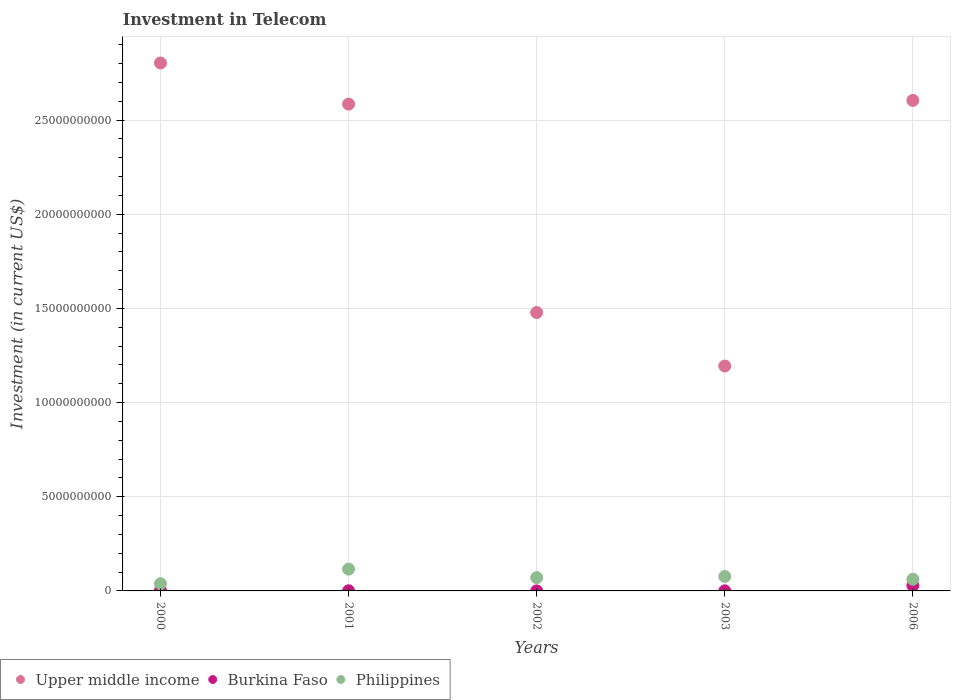How many different coloured dotlines are there?
Offer a very short reply. 3. What is the amount invested in telecom in Philippines in 2001?
Provide a short and direct response. 1.16e+09. Across all years, what is the maximum amount invested in telecom in Upper middle income?
Your response must be concise. 2.80e+1. Across all years, what is the minimum amount invested in telecom in Upper middle income?
Ensure brevity in your answer.  1.19e+1. In which year was the amount invested in telecom in Philippines minimum?
Offer a terse response. 2000. What is the total amount invested in telecom in Philippines in the graph?
Your response must be concise. 3.63e+09. What is the difference between the amount invested in telecom in Upper middle income in 2002 and that in 2003?
Ensure brevity in your answer.  2.84e+09. What is the difference between the amount invested in telecom in Philippines in 2003 and the amount invested in telecom in Burkina Faso in 2001?
Ensure brevity in your answer.  7.59e+08. What is the average amount invested in telecom in Upper middle income per year?
Ensure brevity in your answer.  2.13e+1. In the year 2003, what is the difference between the amount invested in telecom in Upper middle income and amount invested in telecom in Philippines?
Offer a very short reply. 1.12e+1. What is the ratio of the amount invested in telecom in Burkina Faso in 2000 to that in 2003?
Ensure brevity in your answer.  5.22. Is the amount invested in telecom in Philippines in 2000 less than that in 2003?
Provide a succinct answer. Yes. What is the difference between the highest and the second highest amount invested in telecom in Burkina Faso?
Ensure brevity in your answer.  2.63e+08. What is the difference between the highest and the lowest amount invested in telecom in Upper middle income?
Your response must be concise. 1.61e+1. Is the sum of the amount invested in telecom in Philippines in 2001 and 2003 greater than the maximum amount invested in telecom in Burkina Faso across all years?
Provide a succinct answer. Yes. Is it the case that in every year, the sum of the amount invested in telecom in Upper middle income and amount invested in telecom in Burkina Faso  is greater than the amount invested in telecom in Philippines?
Your answer should be compact. Yes. Does the amount invested in telecom in Upper middle income monotonically increase over the years?
Keep it short and to the point. No. Is the amount invested in telecom in Burkina Faso strictly less than the amount invested in telecom in Philippines over the years?
Offer a very short reply. Yes. How many dotlines are there?
Your response must be concise. 3. Does the graph contain any zero values?
Keep it short and to the point. No. Where does the legend appear in the graph?
Keep it short and to the point. Bottom left. How are the legend labels stacked?
Give a very brief answer. Horizontal. What is the title of the graph?
Offer a very short reply. Investment in Telecom. Does "Estonia" appear as one of the legend labels in the graph?
Your answer should be very brief. No. What is the label or title of the X-axis?
Give a very brief answer. Years. What is the label or title of the Y-axis?
Your answer should be compact. Investment (in current US$). What is the Investment (in current US$) of Upper middle income in 2000?
Give a very brief answer. 2.80e+1. What is the Investment (in current US$) of Burkina Faso in 2000?
Offer a very short reply. 2.74e+07. What is the Investment (in current US$) in Philippines in 2000?
Provide a succinct answer. 3.84e+08. What is the Investment (in current US$) of Upper middle income in 2001?
Your answer should be very brief. 2.58e+1. What is the Investment (in current US$) in Burkina Faso in 2001?
Offer a terse response. 8.20e+06. What is the Investment (in current US$) of Philippines in 2001?
Give a very brief answer. 1.16e+09. What is the Investment (in current US$) in Upper middle income in 2002?
Ensure brevity in your answer.  1.48e+1. What is the Investment (in current US$) of Philippines in 2002?
Ensure brevity in your answer.  7.06e+08. What is the Investment (in current US$) in Upper middle income in 2003?
Offer a very short reply. 1.19e+1. What is the Investment (in current US$) of Burkina Faso in 2003?
Make the answer very short. 5.25e+06. What is the Investment (in current US$) in Philippines in 2003?
Keep it short and to the point. 7.67e+08. What is the Investment (in current US$) of Upper middle income in 2006?
Your answer should be compact. 2.60e+1. What is the Investment (in current US$) of Burkina Faso in 2006?
Provide a short and direct response. 2.90e+08. What is the Investment (in current US$) of Philippines in 2006?
Give a very brief answer. 6.19e+08. Across all years, what is the maximum Investment (in current US$) in Upper middle income?
Offer a very short reply. 2.80e+1. Across all years, what is the maximum Investment (in current US$) of Burkina Faso?
Your response must be concise. 2.90e+08. Across all years, what is the maximum Investment (in current US$) of Philippines?
Your response must be concise. 1.16e+09. Across all years, what is the minimum Investment (in current US$) of Upper middle income?
Offer a terse response. 1.19e+1. Across all years, what is the minimum Investment (in current US$) in Burkina Faso?
Provide a succinct answer. 1.00e+06. Across all years, what is the minimum Investment (in current US$) in Philippines?
Ensure brevity in your answer.  3.84e+08. What is the total Investment (in current US$) in Upper middle income in the graph?
Offer a terse response. 1.07e+11. What is the total Investment (in current US$) of Burkina Faso in the graph?
Your answer should be very brief. 3.32e+08. What is the total Investment (in current US$) of Philippines in the graph?
Provide a succinct answer. 3.63e+09. What is the difference between the Investment (in current US$) of Upper middle income in 2000 and that in 2001?
Your answer should be very brief. 2.18e+09. What is the difference between the Investment (in current US$) of Burkina Faso in 2000 and that in 2001?
Your answer should be very brief. 1.92e+07. What is the difference between the Investment (in current US$) in Philippines in 2000 and that in 2001?
Your answer should be very brief. -7.73e+08. What is the difference between the Investment (in current US$) in Upper middle income in 2000 and that in 2002?
Your response must be concise. 1.33e+1. What is the difference between the Investment (in current US$) of Burkina Faso in 2000 and that in 2002?
Your answer should be very brief. 2.64e+07. What is the difference between the Investment (in current US$) in Philippines in 2000 and that in 2002?
Your answer should be compact. -3.22e+08. What is the difference between the Investment (in current US$) in Upper middle income in 2000 and that in 2003?
Your answer should be compact. 1.61e+1. What is the difference between the Investment (in current US$) in Burkina Faso in 2000 and that in 2003?
Provide a succinct answer. 2.22e+07. What is the difference between the Investment (in current US$) in Philippines in 2000 and that in 2003?
Offer a very short reply. -3.83e+08. What is the difference between the Investment (in current US$) in Upper middle income in 2000 and that in 2006?
Your answer should be very brief. 1.99e+09. What is the difference between the Investment (in current US$) in Burkina Faso in 2000 and that in 2006?
Ensure brevity in your answer.  -2.63e+08. What is the difference between the Investment (in current US$) in Philippines in 2000 and that in 2006?
Give a very brief answer. -2.35e+08. What is the difference between the Investment (in current US$) in Upper middle income in 2001 and that in 2002?
Give a very brief answer. 1.11e+1. What is the difference between the Investment (in current US$) in Burkina Faso in 2001 and that in 2002?
Give a very brief answer. 7.20e+06. What is the difference between the Investment (in current US$) in Philippines in 2001 and that in 2002?
Keep it short and to the point. 4.51e+08. What is the difference between the Investment (in current US$) of Upper middle income in 2001 and that in 2003?
Provide a short and direct response. 1.39e+1. What is the difference between the Investment (in current US$) in Burkina Faso in 2001 and that in 2003?
Ensure brevity in your answer.  2.95e+06. What is the difference between the Investment (in current US$) in Philippines in 2001 and that in 2003?
Provide a short and direct response. 3.90e+08. What is the difference between the Investment (in current US$) of Upper middle income in 2001 and that in 2006?
Provide a short and direct response. -1.96e+08. What is the difference between the Investment (in current US$) in Burkina Faso in 2001 and that in 2006?
Ensure brevity in your answer.  -2.82e+08. What is the difference between the Investment (in current US$) in Philippines in 2001 and that in 2006?
Provide a short and direct response. 5.38e+08. What is the difference between the Investment (in current US$) of Upper middle income in 2002 and that in 2003?
Make the answer very short. 2.84e+09. What is the difference between the Investment (in current US$) in Burkina Faso in 2002 and that in 2003?
Keep it short and to the point. -4.25e+06. What is the difference between the Investment (in current US$) in Philippines in 2002 and that in 2003?
Provide a succinct answer. -6.07e+07. What is the difference between the Investment (in current US$) of Upper middle income in 2002 and that in 2006?
Keep it short and to the point. -1.13e+1. What is the difference between the Investment (in current US$) in Burkina Faso in 2002 and that in 2006?
Provide a short and direct response. -2.89e+08. What is the difference between the Investment (in current US$) in Philippines in 2002 and that in 2006?
Your answer should be very brief. 8.75e+07. What is the difference between the Investment (in current US$) of Upper middle income in 2003 and that in 2006?
Your answer should be very brief. -1.41e+1. What is the difference between the Investment (in current US$) of Burkina Faso in 2003 and that in 2006?
Your answer should be very brief. -2.85e+08. What is the difference between the Investment (in current US$) in Philippines in 2003 and that in 2006?
Give a very brief answer. 1.48e+08. What is the difference between the Investment (in current US$) in Upper middle income in 2000 and the Investment (in current US$) in Burkina Faso in 2001?
Ensure brevity in your answer.  2.80e+1. What is the difference between the Investment (in current US$) in Upper middle income in 2000 and the Investment (in current US$) in Philippines in 2001?
Your answer should be compact. 2.69e+1. What is the difference between the Investment (in current US$) of Burkina Faso in 2000 and the Investment (in current US$) of Philippines in 2001?
Your answer should be compact. -1.13e+09. What is the difference between the Investment (in current US$) in Upper middle income in 2000 and the Investment (in current US$) in Burkina Faso in 2002?
Make the answer very short. 2.80e+1. What is the difference between the Investment (in current US$) of Upper middle income in 2000 and the Investment (in current US$) of Philippines in 2002?
Your response must be concise. 2.73e+1. What is the difference between the Investment (in current US$) in Burkina Faso in 2000 and the Investment (in current US$) in Philippines in 2002?
Offer a terse response. -6.79e+08. What is the difference between the Investment (in current US$) in Upper middle income in 2000 and the Investment (in current US$) in Burkina Faso in 2003?
Your answer should be very brief. 2.80e+1. What is the difference between the Investment (in current US$) in Upper middle income in 2000 and the Investment (in current US$) in Philippines in 2003?
Give a very brief answer. 2.73e+1. What is the difference between the Investment (in current US$) in Burkina Faso in 2000 and the Investment (in current US$) in Philippines in 2003?
Keep it short and to the point. -7.40e+08. What is the difference between the Investment (in current US$) of Upper middle income in 2000 and the Investment (in current US$) of Burkina Faso in 2006?
Your response must be concise. 2.77e+1. What is the difference between the Investment (in current US$) in Upper middle income in 2000 and the Investment (in current US$) in Philippines in 2006?
Offer a very short reply. 2.74e+1. What is the difference between the Investment (in current US$) in Burkina Faso in 2000 and the Investment (in current US$) in Philippines in 2006?
Make the answer very short. -5.92e+08. What is the difference between the Investment (in current US$) of Upper middle income in 2001 and the Investment (in current US$) of Burkina Faso in 2002?
Your answer should be very brief. 2.58e+1. What is the difference between the Investment (in current US$) in Upper middle income in 2001 and the Investment (in current US$) in Philippines in 2002?
Your answer should be very brief. 2.51e+1. What is the difference between the Investment (in current US$) in Burkina Faso in 2001 and the Investment (in current US$) in Philippines in 2002?
Keep it short and to the point. -6.98e+08. What is the difference between the Investment (in current US$) of Upper middle income in 2001 and the Investment (in current US$) of Burkina Faso in 2003?
Offer a terse response. 2.58e+1. What is the difference between the Investment (in current US$) of Upper middle income in 2001 and the Investment (in current US$) of Philippines in 2003?
Your answer should be compact. 2.51e+1. What is the difference between the Investment (in current US$) of Burkina Faso in 2001 and the Investment (in current US$) of Philippines in 2003?
Provide a short and direct response. -7.59e+08. What is the difference between the Investment (in current US$) in Upper middle income in 2001 and the Investment (in current US$) in Burkina Faso in 2006?
Make the answer very short. 2.56e+1. What is the difference between the Investment (in current US$) in Upper middle income in 2001 and the Investment (in current US$) in Philippines in 2006?
Your answer should be compact. 2.52e+1. What is the difference between the Investment (in current US$) of Burkina Faso in 2001 and the Investment (in current US$) of Philippines in 2006?
Your answer should be very brief. -6.11e+08. What is the difference between the Investment (in current US$) of Upper middle income in 2002 and the Investment (in current US$) of Burkina Faso in 2003?
Ensure brevity in your answer.  1.48e+1. What is the difference between the Investment (in current US$) of Upper middle income in 2002 and the Investment (in current US$) of Philippines in 2003?
Keep it short and to the point. 1.40e+1. What is the difference between the Investment (in current US$) of Burkina Faso in 2002 and the Investment (in current US$) of Philippines in 2003?
Provide a short and direct response. -7.66e+08. What is the difference between the Investment (in current US$) in Upper middle income in 2002 and the Investment (in current US$) in Burkina Faso in 2006?
Make the answer very short. 1.45e+1. What is the difference between the Investment (in current US$) in Upper middle income in 2002 and the Investment (in current US$) in Philippines in 2006?
Offer a terse response. 1.42e+1. What is the difference between the Investment (in current US$) in Burkina Faso in 2002 and the Investment (in current US$) in Philippines in 2006?
Your answer should be very brief. -6.18e+08. What is the difference between the Investment (in current US$) in Upper middle income in 2003 and the Investment (in current US$) in Burkina Faso in 2006?
Offer a very short reply. 1.17e+1. What is the difference between the Investment (in current US$) in Upper middle income in 2003 and the Investment (in current US$) in Philippines in 2006?
Your answer should be very brief. 1.13e+1. What is the difference between the Investment (in current US$) of Burkina Faso in 2003 and the Investment (in current US$) of Philippines in 2006?
Offer a very short reply. -6.14e+08. What is the average Investment (in current US$) of Upper middle income per year?
Your answer should be very brief. 2.13e+1. What is the average Investment (in current US$) in Burkina Faso per year?
Your response must be concise. 6.64e+07. What is the average Investment (in current US$) of Philippines per year?
Offer a terse response. 7.27e+08. In the year 2000, what is the difference between the Investment (in current US$) in Upper middle income and Investment (in current US$) in Burkina Faso?
Offer a very short reply. 2.80e+1. In the year 2000, what is the difference between the Investment (in current US$) of Upper middle income and Investment (in current US$) of Philippines?
Your answer should be compact. 2.76e+1. In the year 2000, what is the difference between the Investment (in current US$) in Burkina Faso and Investment (in current US$) in Philippines?
Offer a very short reply. -3.57e+08. In the year 2001, what is the difference between the Investment (in current US$) of Upper middle income and Investment (in current US$) of Burkina Faso?
Ensure brevity in your answer.  2.58e+1. In the year 2001, what is the difference between the Investment (in current US$) of Upper middle income and Investment (in current US$) of Philippines?
Offer a very short reply. 2.47e+1. In the year 2001, what is the difference between the Investment (in current US$) in Burkina Faso and Investment (in current US$) in Philippines?
Provide a short and direct response. -1.15e+09. In the year 2002, what is the difference between the Investment (in current US$) in Upper middle income and Investment (in current US$) in Burkina Faso?
Make the answer very short. 1.48e+1. In the year 2002, what is the difference between the Investment (in current US$) of Upper middle income and Investment (in current US$) of Philippines?
Provide a short and direct response. 1.41e+1. In the year 2002, what is the difference between the Investment (in current US$) of Burkina Faso and Investment (in current US$) of Philippines?
Offer a very short reply. -7.05e+08. In the year 2003, what is the difference between the Investment (in current US$) in Upper middle income and Investment (in current US$) in Burkina Faso?
Keep it short and to the point. 1.19e+1. In the year 2003, what is the difference between the Investment (in current US$) of Upper middle income and Investment (in current US$) of Philippines?
Your answer should be compact. 1.12e+1. In the year 2003, what is the difference between the Investment (in current US$) in Burkina Faso and Investment (in current US$) in Philippines?
Give a very brief answer. -7.62e+08. In the year 2006, what is the difference between the Investment (in current US$) in Upper middle income and Investment (in current US$) in Burkina Faso?
Make the answer very short. 2.58e+1. In the year 2006, what is the difference between the Investment (in current US$) in Upper middle income and Investment (in current US$) in Philippines?
Make the answer very short. 2.54e+1. In the year 2006, what is the difference between the Investment (in current US$) in Burkina Faso and Investment (in current US$) in Philippines?
Your answer should be very brief. -3.29e+08. What is the ratio of the Investment (in current US$) of Upper middle income in 2000 to that in 2001?
Offer a terse response. 1.08. What is the ratio of the Investment (in current US$) of Burkina Faso in 2000 to that in 2001?
Offer a terse response. 3.34. What is the ratio of the Investment (in current US$) in Philippines in 2000 to that in 2001?
Offer a very short reply. 0.33. What is the ratio of the Investment (in current US$) in Upper middle income in 2000 to that in 2002?
Offer a terse response. 1.9. What is the ratio of the Investment (in current US$) of Burkina Faso in 2000 to that in 2002?
Ensure brevity in your answer.  27.4. What is the ratio of the Investment (in current US$) in Philippines in 2000 to that in 2002?
Your response must be concise. 0.54. What is the ratio of the Investment (in current US$) in Upper middle income in 2000 to that in 2003?
Keep it short and to the point. 2.35. What is the ratio of the Investment (in current US$) in Burkina Faso in 2000 to that in 2003?
Offer a very short reply. 5.22. What is the ratio of the Investment (in current US$) of Philippines in 2000 to that in 2003?
Offer a terse response. 0.5. What is the ratio of the Investment (in current US$) of Upper middle income in 2000 to that in 2006?
Make the answer very short. 1.08. What is the ratio of the Investment (in current US$) in Burkina Faso in 2000 to that in 2006?
Keep it short and to the point. 0.09. What is the ratio of the Investment (in current US$) in Philippines in 2000 to that in 2006?
Offer a terse response. 0.62. What is the ratio of the Investment (in current US$) in Upper middle income in 2001 to that in 2002?
Ensure brevity in your answer.  1.75. What is the ratio of the Investment (in current US$) in Burkina Faso in 2001 to that in 2002?
Your answer should be very brief. 8.2. What is the ratio of the Investment (in current US$) in Philippines in 2001 to that in 2002?
Make the answer very short. 1.64. What is the ratio of the Investment (in current US$) of Upper middle income in 2001 to that in 2003?
Your response must be concise. 2.16. What is the ratio of the Investment (in current US$) in Burkina Faso in 2001 to that in 2003?
Make the answer very short. 1.56. What is the ratio of the Investment (in current US$) in Philippines in 2001 to that in 2003?
Offer a terse response. 1.51. What is the ratio of the Investment (in current US$) in Burkina Faso in 2001 to that in 2006?
Your response must be concise. 0.03. What is the ratio of the Investment (in current US$) of Philippines in 2001 to that in 2006?
Offer a very short reply. 1.87. What is the ratio of the Investment (in current US$) in Upper middle income in 2002 to that in 2003?
Make the answer very short. 1.24. What is the ratio of the Investment (in current US$) of Burkina Faso in 2002 to that in 2003?
Provide a short and direct response. 0.19. What is the ratio of the Investment (in current US$) in Philippines in 2002 to that in 2003?
Ensure brevity in your answer.  0.92. What is the ratio of the Investment (in current US$) of Upper middle income in 2002 to that in 2006?
Ensure brevity in your answer.  0.57. What is the ratio of the Investment (in current US$) of Burkina Faso in 2002 to that in 2006?
Give a very brief answer. 0. What is the ratio of the Investment (in current US$) of Philippines in 2002 to that in 2006?
Give a very brief answer. 1.14. What is the ratio of the Investment (in current US$) in Upper middle income in 2003 to that in 2006?
Keep it short and to the point. 0.46. What is the ratio of the Investment (in current US$) of Burkina Faso in 2003 to that in 2006?
Your answer should be very brief. 0.02. What is the ratio of the Investment (in current US$) in Philippines in 2003 to that in 2006?
Provide a succinct answer. 1.24. What is the difference between the highest and the second highest Investment (in current US$) in Upper middle income?
Make the answer very short. 1.99e+09. What is the difference between the highest and the second highest Investment (in current US$) of Burkina Faso?
Offer a terse response. 2.63e+08. What is the difference between the highest and the second highest Investment (in current US$) in Philippines?
Offer a very short reply. 3.90e+08. What is the difference between the highest and the lowest Investment (in current US$) of Upper middle income?
Keep it short and to the point. 1.61e+1. What is the difference between the highest and the lowest Investment (in current US$) in Burkina Faso?
Keep it short and to the point. 2.89e+08. What is the difference between the highest and the lowest Investment (in current US$) in Philippines?
Offer a very short reply. 7.73e+08. 